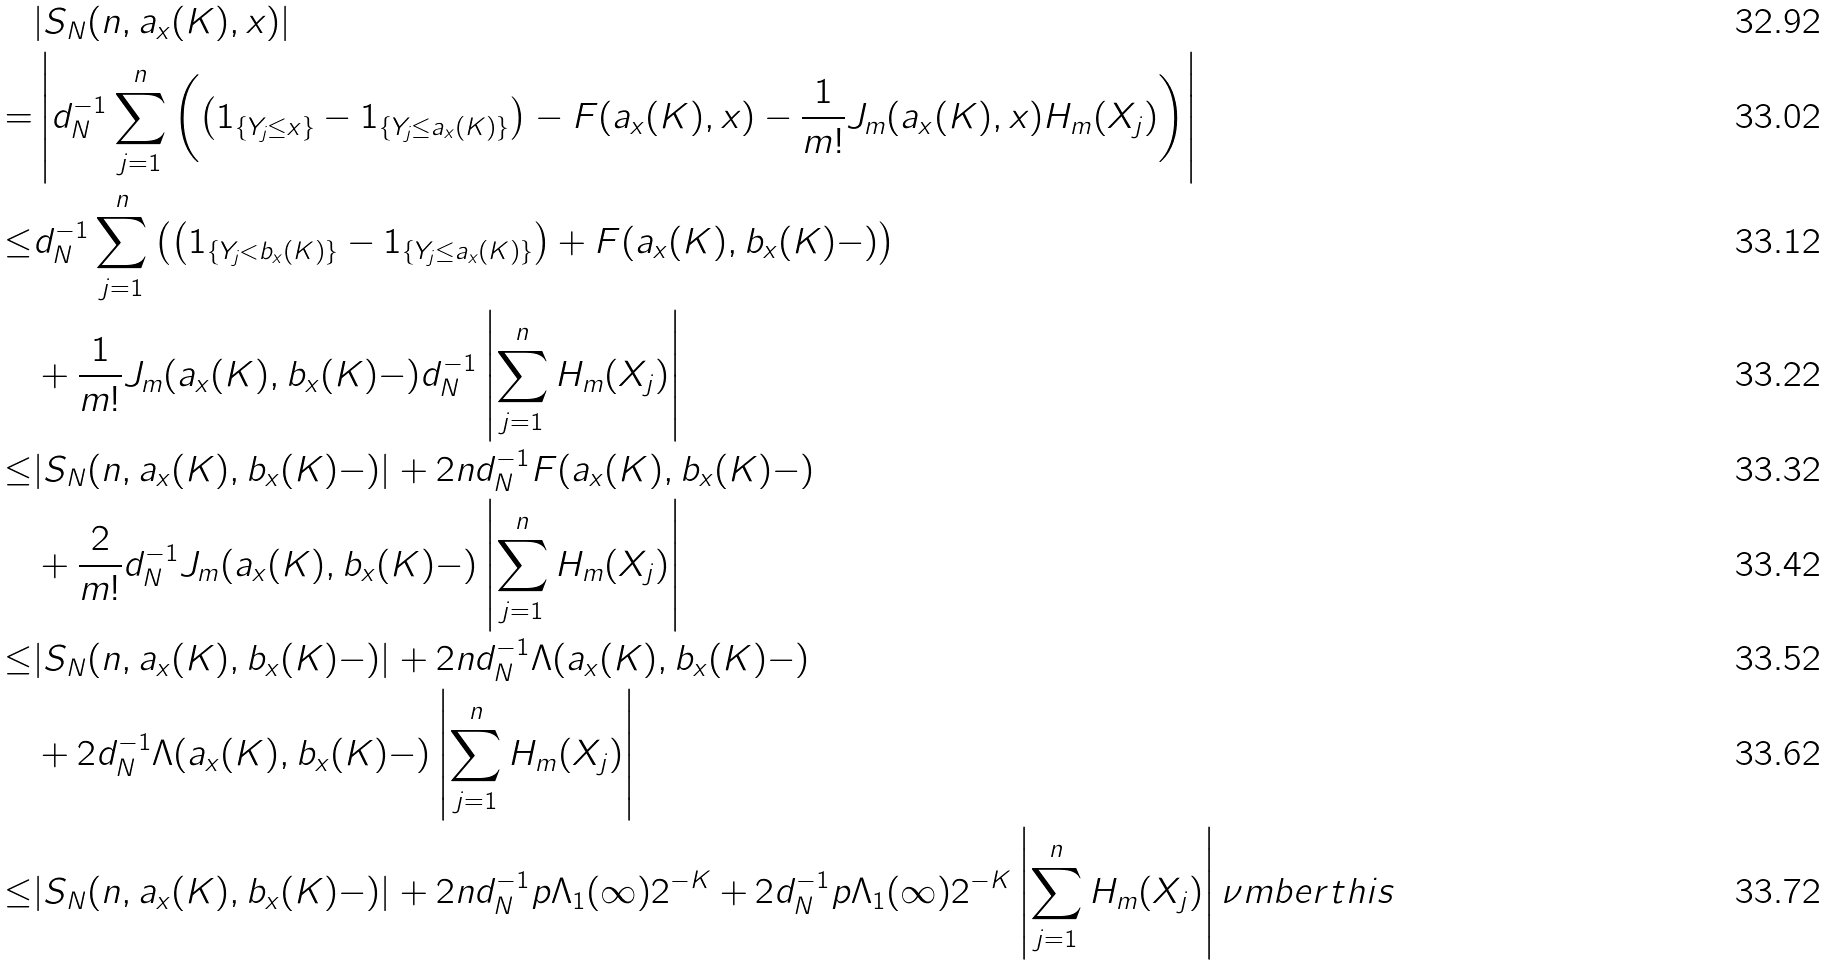Convert formula to latex. <formula><loc_0><loc_0><loc_500><loc_500>& | S _ { N } ( n , a _ { x } ( K ) , x ) | \\ = & \left | d _ { N } ^ { - 1 } \sum _ { j = 1 } ^ { n } \left ( \left ( 1 _ { \{ Y _ { j } \leq x \} } - 1 _ { \{ Y _ { j } \leq a _ { x } ( K ) \} } \right ) - F ( a _ { x } ( K ) , x ) - \frac { 1 } { m ! } J _ { m } ( a _ { x } ( K ) , x ) H _ { m } ( X _ { j } ) \right ) \right | \\ \leq & d _ { N } ^ { - 1 } \sum _ { j = 1 } ^ { n } \left ( \left ( 1 _ { \{ Y _ { j } < b _ { x } ( K ) \} } - 1 _ { \{ Y _ { j } \leq a _ { x } ( K ) \} } \right ) + F ( a _ { x } ( K ) , b _ { x } ( K ) - ) \right ) \\ & + \frac { 1 } { m ! } J _ { m } ( a _ { x } ( K ) , b _ { x } ( K ) - ) d _ { N } ^ { - 1 } \left | \sum _ { j = 1 } ^ { n } H _ { m } ( X _ { j } ) \right | \\ \leq & | S _ { N } ( n , a _ { x } ( K ) , b _ { x } ( K ) - ) | + 2 n d _ { N } ^ { - 1 } F ( a _ { x } ( K ) , b _ { x } ( K ) - ) \\ & + \frac { 2 } { m ! } d _ { N } ^ { - 1 } J _ { m } ( a _ { x } ( K ) , b _ { x } ( K ) - ) \left | \sum _ { j = 1 } ^ { n } H _ { m } ( X _ { j } ) \right | \\ \leq & | S _ { N } ( n , a _ { x } ( K ) , b _ { x } ( K ) - ) | + 2 n d _ { N } ^ { - 1 } \Lambda ( a _ { x } ( K ) , b _ { x } ( K ) - ) \\ & + 2 d _ { N } ^ { - 1 } \Lambda ( a _ { x } ( K ) , b _ { x } ( K ) - ) \left | \sum _ { j = 1 } ^ { n } H _ { m } ( X _ { j } ) \right | \\ \leq & | S _ { N } ( n , a _ { x } ( K ) , b _ { x } ( K ) - ) | + 2 n d _ { N } ^ { - 1 } p \Lambda _ { 1 } ( \infty ) 2 ^ { - K } + 2 d _ { N } ^ { - 1 } p \Lambda _ { 1 } ( \infty ) 2 ^ { - K } \left | \sum _ { j = 1 } ^ { n } H _ { m } ( X _ { j } ) \right | \nu m b e r t h i s</formula> 